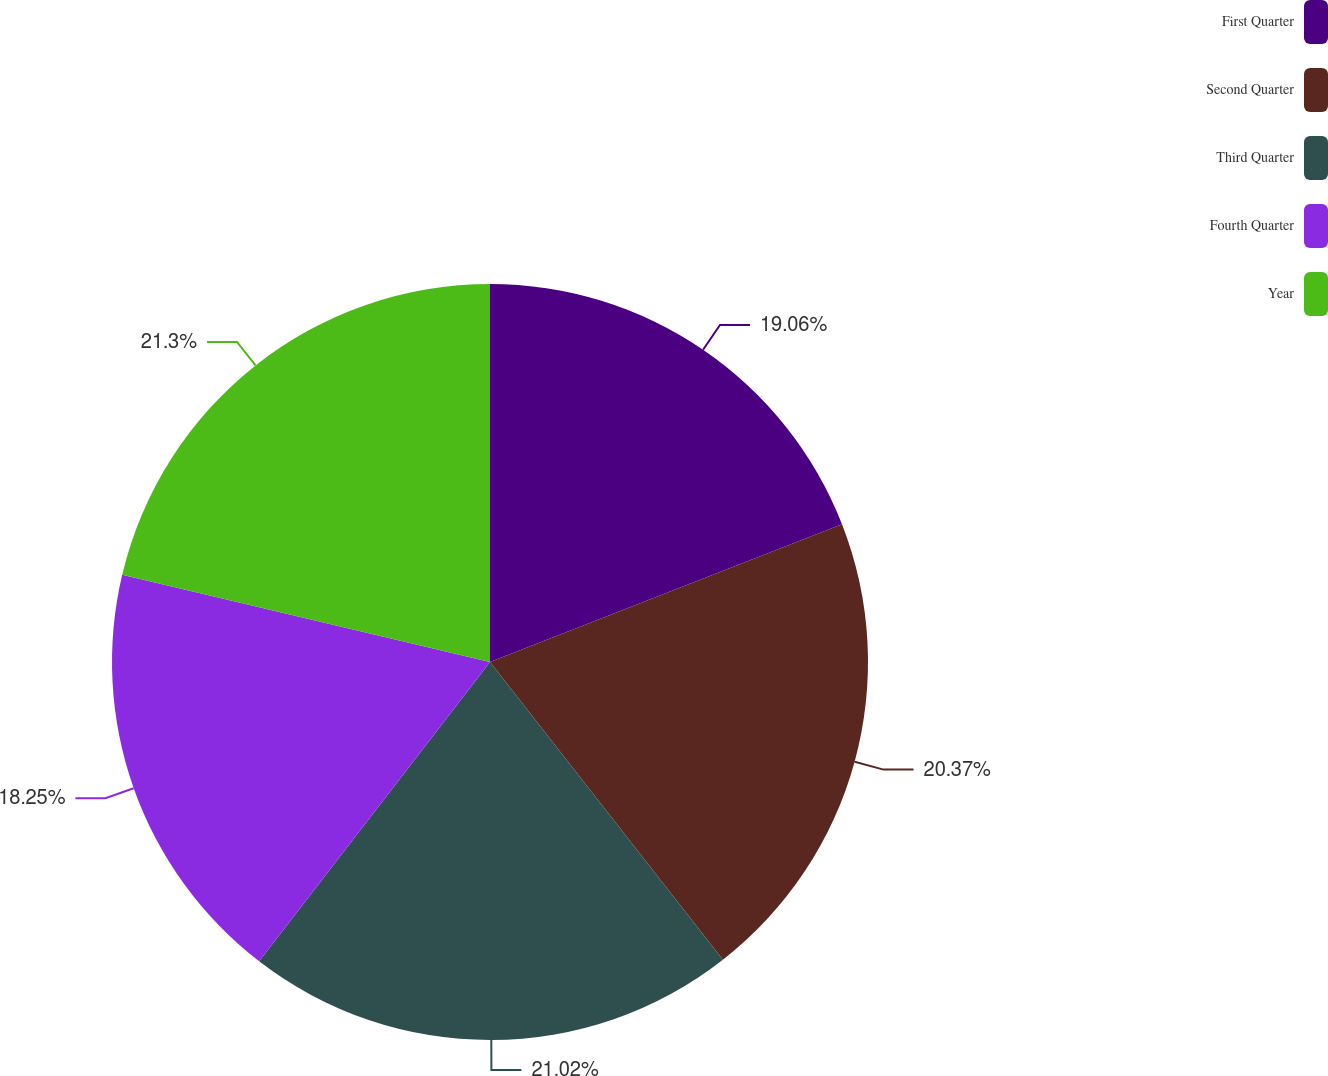Convert chart to OTSL. <chart><loc_0><loc_0><loc_500><loc_500><pie_chart><fcel>First Quarter<fcel>Second Quarter<fcel>Third Quarter<fcel>Fourth Quarter<fcel>Year<nl><fcel>19.06%<fcel>20.37%<fcel>21.02%<fcel>18.25%<fcel>21.29%<nl></chart> 